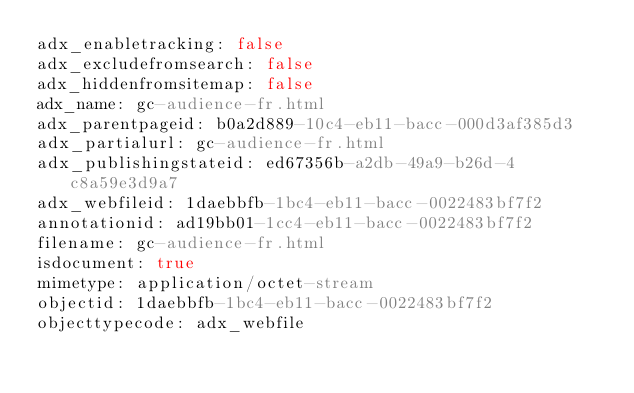Convert code to text. <code><loc_0><loc_0><loc_500><loc_500><_YAML_>adx_enabletracking: false
adx_excludefromsearch: false
adx_hiddenfromsitemap: false
adx_name: gc-audience-fr.html
adx_parentpageid: b0a2d889-10c4-eb11-bacc-000d3af385d3
adx_partialurl: gc-audience-fr.html
adx_publishingstateid: ed67356b-a2db-49a9-b26d-4c8a59e3d9a7
adx_webfileid: 1daebbfb-1bc4-eb11-bacc-0022483bf7f2
annotationid: ad19bb01-1cc4-eb11-bacc-0022483bf7f2
filename: gc-audience-fr.html
isdocument: true
mimetype: application/octet-stream
objectid: 1daebbfb-1bc4-eb11-bacc-0022483bf7f2
objecttypecode: adx_webfile
</code> 